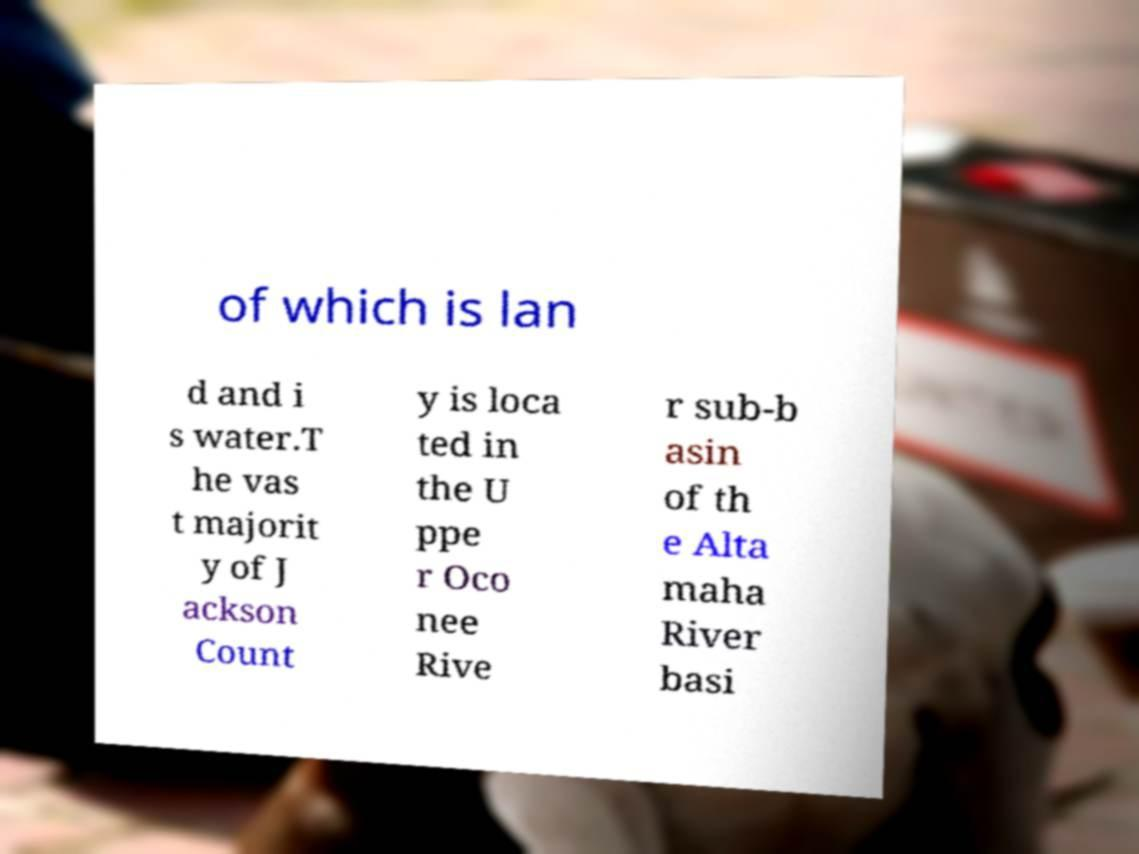There's text embedded in this image that I need extracted. Can you transcribe it verbatim? of which is lan d and i s water.T he vas t majorit y of J ackson Count y is loca ted in the U ppe r Oco nee Rive r sub-b asin of th e Alta maha River basi 